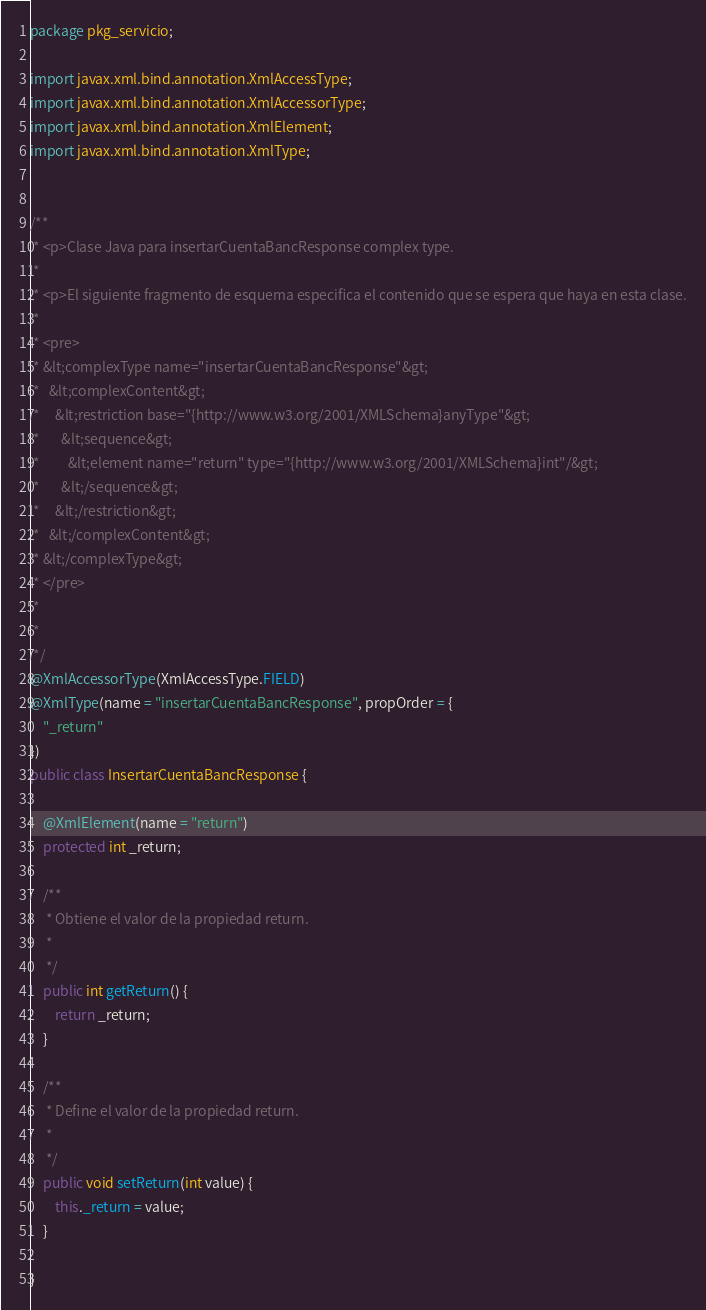Convert code to text. <code><loc_0><loc_0><loc_500><loc_500><_Java_>
package pkg_servicio;

import javax.xml.bind.annotation.XmlAccessType;
import javax.xml.bind.annotation.XmlAccessorType;
import javax.xml.bind.annotation.XmlElement;
import javax.xml.bind.annotation.XmlType;


/**
 * <p>Clase Java para insertarCuentaBancResponse complex type.
 * 
 * <p>El siguiente fragmento de esquema especifica el contenido que se espera que haya en esta clase.
 * 
 * <pre>
 * &lt;complexType name="insertarCuentaBancResponse"&gt;
 *   &lt;complexContent&gt;
 *     &lt;restriction base="{http://www.w3.org/2001/XMLSchema}anyType"&gt;
 *       &lt;sequence&gt;
 *         &lt;element name="return" type="{http://www.w3.org/2001/XMLSchema}int"/&gt;
 *       &lt;/sequence&gt;
 *     &lt;/restriction&gt;
 *   &lt;/complexContent&gt;
 * &lt;/complexType&gt;
 * </pre>
 * 
 * 
 */
@XmlAccessorType(XmlAccessType.FIELD)
@XmlType(name = "insertarCuentaBancResponse", propOrder = {
    "_return"
})
public class InsertarCuentaBancResponse {

    @XmlElement(name = "return")
    protected int _return;

    /**
     * Obtiene el valor de la propiedad return.
     * 
     */
    public int getReturn() {
        return _return;
    }

    /**
     * Define el valor de la propiedad return.
     * 
     */
    public void setReturn(int value) {
        this._return = value;
    }

}
</code> 